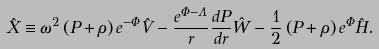<formula> <loc_0><loc_0><loc_500><loc_500>\hat { X } \equiv \omega ^ { 2 } \left ( P + \rho \right ) e ^ { - \Phi } \hat { V } - \frac { e ^ { \Phi - \Lambda } } { r } \frac { d P } { d r } \hat { W } - \frac { 1 } { 2 } \left ( P + \rho \right ) e ^ { \Phi } \hat { H } .</formula> 